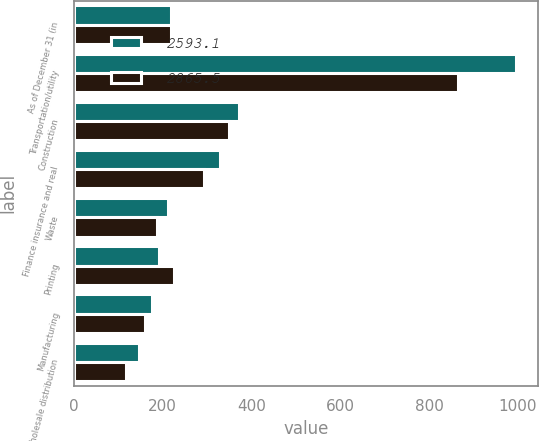<chart> <loc_0><loc_0><loc_500><loc_500><stacked_bar_chart><ecel><fcel>As of December 31 (in<fcel>Transportation/utility<fcel>Construction<fcel>Finance insurance and real<fcel>Waste<fcel>Printing<fcel>Manufacturing<fcel>Wholesale distribution<nl><fcel>2593.1<fcel>219.1<fcel>994.8<fcel>371.4<fcel>328.3<fcel>211.8<fcel>192.5<fcel>174.9<fcel>146.8<nl><fcel>2865.5<fcel>219.1<fcel>864.5<fcel>348.4<fcel>292.5<fcel>187.9<fcel>226.4<fcel>159.4<fcel>117.1<nl></chart> 